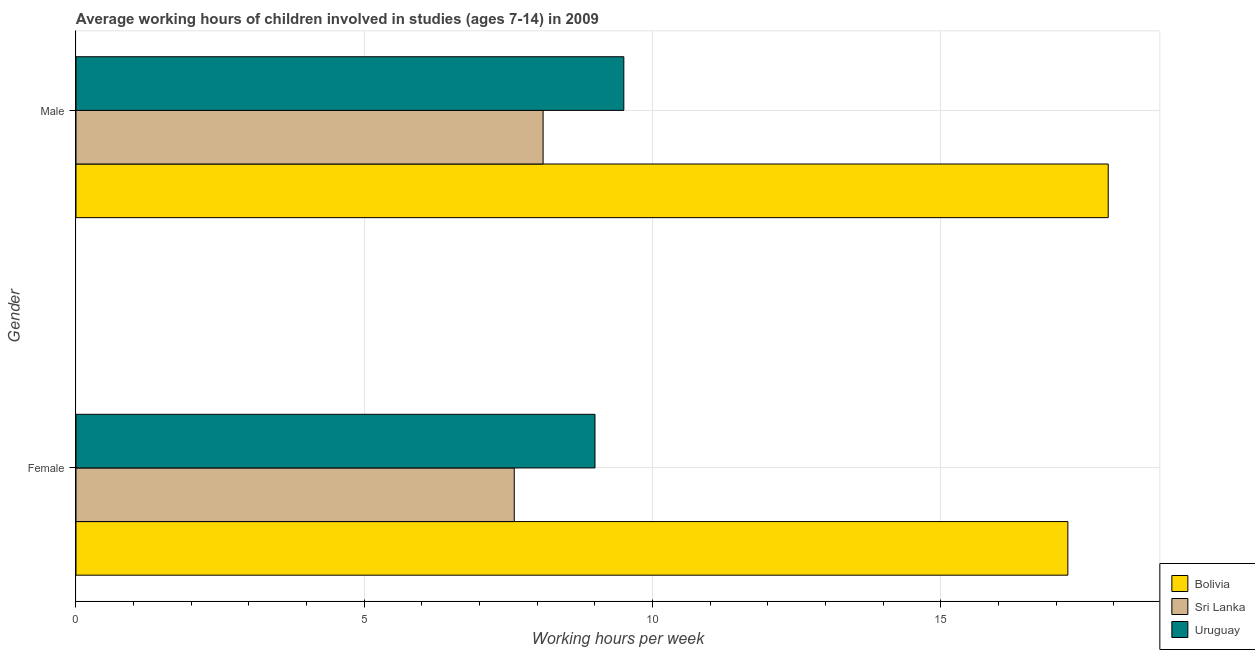How many groups of bars are there?
Your answer should be very brief. 2. How many bars are there on the 1st tick from the bottom?
Give a very brief answer. 3. Across all countries, what is the maximum average working hour of female children?
Give a very brief answer. 17.2. Across all countries, what is the minimum average working hour of female children?
Offer a very short reply. 7.6. In which country was the average working hour of male children minimum?
Your answer should be compact. Sri Lanka. What is the total average working hour of male children in the graph?
Offer a terse response. 35.5. What is the difference between the average working hour of male children in Bolivia and the average working hour of female children in Sri Lanka?
Provide a succinct answer. 10.3. What is the average average working hour of female children per country?
Provide a succinct answer. 11.27. What is the difference between the average working hour of female children and average working hour of male children in Uruguay?
Keep it short and to the point. -0.5. In how many countries, is the average working hour of male children greater than 8 hours?
Make the answer very short. 3. What is the ratio of the average working hour of female children in Sri Lanka to that in Uruguay?
Your response must be concise. 0.84. Is the average working hour of female children in Sri Lanka less than that in Bolivia?
Ensure brevity in your answer.  Yes. What does the 1st bar from the top in Male represents?
Keep it short and to the point. Uruguay. What does the 2nd bar from the bottom in Male represents?
Offer a very short reply. Sri Lanka. How many bars are there?
Offer a terse response. 6. How many countries are there in the graph?
Make the answer very short. 3. Are the values on the major ticks of X-axis written in scientific E-notation?
Keep it short and to the point. No. Does the graph contain any zero values?
Offer a terse response. No. Does the graph contain grids?
Give a very brief answer. Yes. How many legend labels are there?
Provide a succinct answer. 3. How are the legend labels stacked?
Provide a short and direct response. Vertical. What is the title of the graph?
Make the answer very short. Average working hours of children involved in studies (ages 7-14) in 2009. What is the label or title of the X-axis?
Your answer should be very brief. Working hours per week. What is the Working hours per week of Bolivia in Female?
Your answer should be very brief. 17.2. What is the Working hours per week in Sri Lanka in Female?
Provide a short and direct response. 7.6. Across all Gender, what is the maximum Working hours per week of Uruguay?
Offer a very short reply. 9.5. Across all Gender, what is the minimum Working hours per week of Sri Lanka?
Make the answer very short. 7.6. What is the total Working hours per week of Bolivia in the graph?
Keep it short and to the point. 35.1. What is the total Working hours per week in Sri Lanka in the graph?
Give a very brief answer. 15.7. What is the difference between the Working hours per week of Sri Lanka in Female and that in Male?
Ensure brevity in your answer.  -0.5. What is the difference between the Working hours per week in Uruguay in Female and that in Male?
Provide a succinct answer. -0.5. What is the difference between the Working hours per week in Bolivia in Female and the Working hours per week in Uruguay in Male?
Your response must be concise. 7.7. What is the difference between the Working hours per week of Sri Lanka in Female and the Working hours per week of Uruguay in Male?
Make the answer very short. -1.9. What is the average Working hours per week of Bolivia per Gender?
Offer a very short reply. 17.55. What is the average Working hours per week in Sri Lanka per Gender?
Provide a succinct answer. 7.85. What is the average Working hours per week in Uruguay per Gender?
Give a very brief answer. 9.25. What is the difference between the Working hours per week of Bolivia and Working hours per week of Sri Lanka in Female?
Your answer should be compact. 9.6. What is the difference between the Working hours per week of Sri Lanka and Working hours per week of Uruguay in Female?
Your answer should be very brief. -1.4. What is the difference between the Working hours per week in Bolivia and Working hours per week in Sri Lanka in Male?
Your response must be concise. 9.8. What is the difference between the Working hours per week of Bolivia and Working hours per week of Uruguay in Male?
Offer a terse response. 8.4. What is the ratio of the Working hours per week in Bolivia in Female to that in Male?
Ensure brevity in your answer.  0.96. What is the ratio of the Working hours per week in Sri Lanka in Female to that in Male?
Offer a terse response. 0.94. What is the ratio of the Working hours per week of Uruguay in Female to that in Male?
Provide a succinct answer. 0.95. What is the difference between the highest and the second highest Working hours per week in Uruguay?
Offer a very short reply. 0.5. What is the difference between the highest and the lowest Working hours per week in Sri Lanka?
Your answer should be compact. 0.5. What is the difference between the highest and the lowest Working hours per week in Uruguay?
Offer a very short reply. 0.5. 